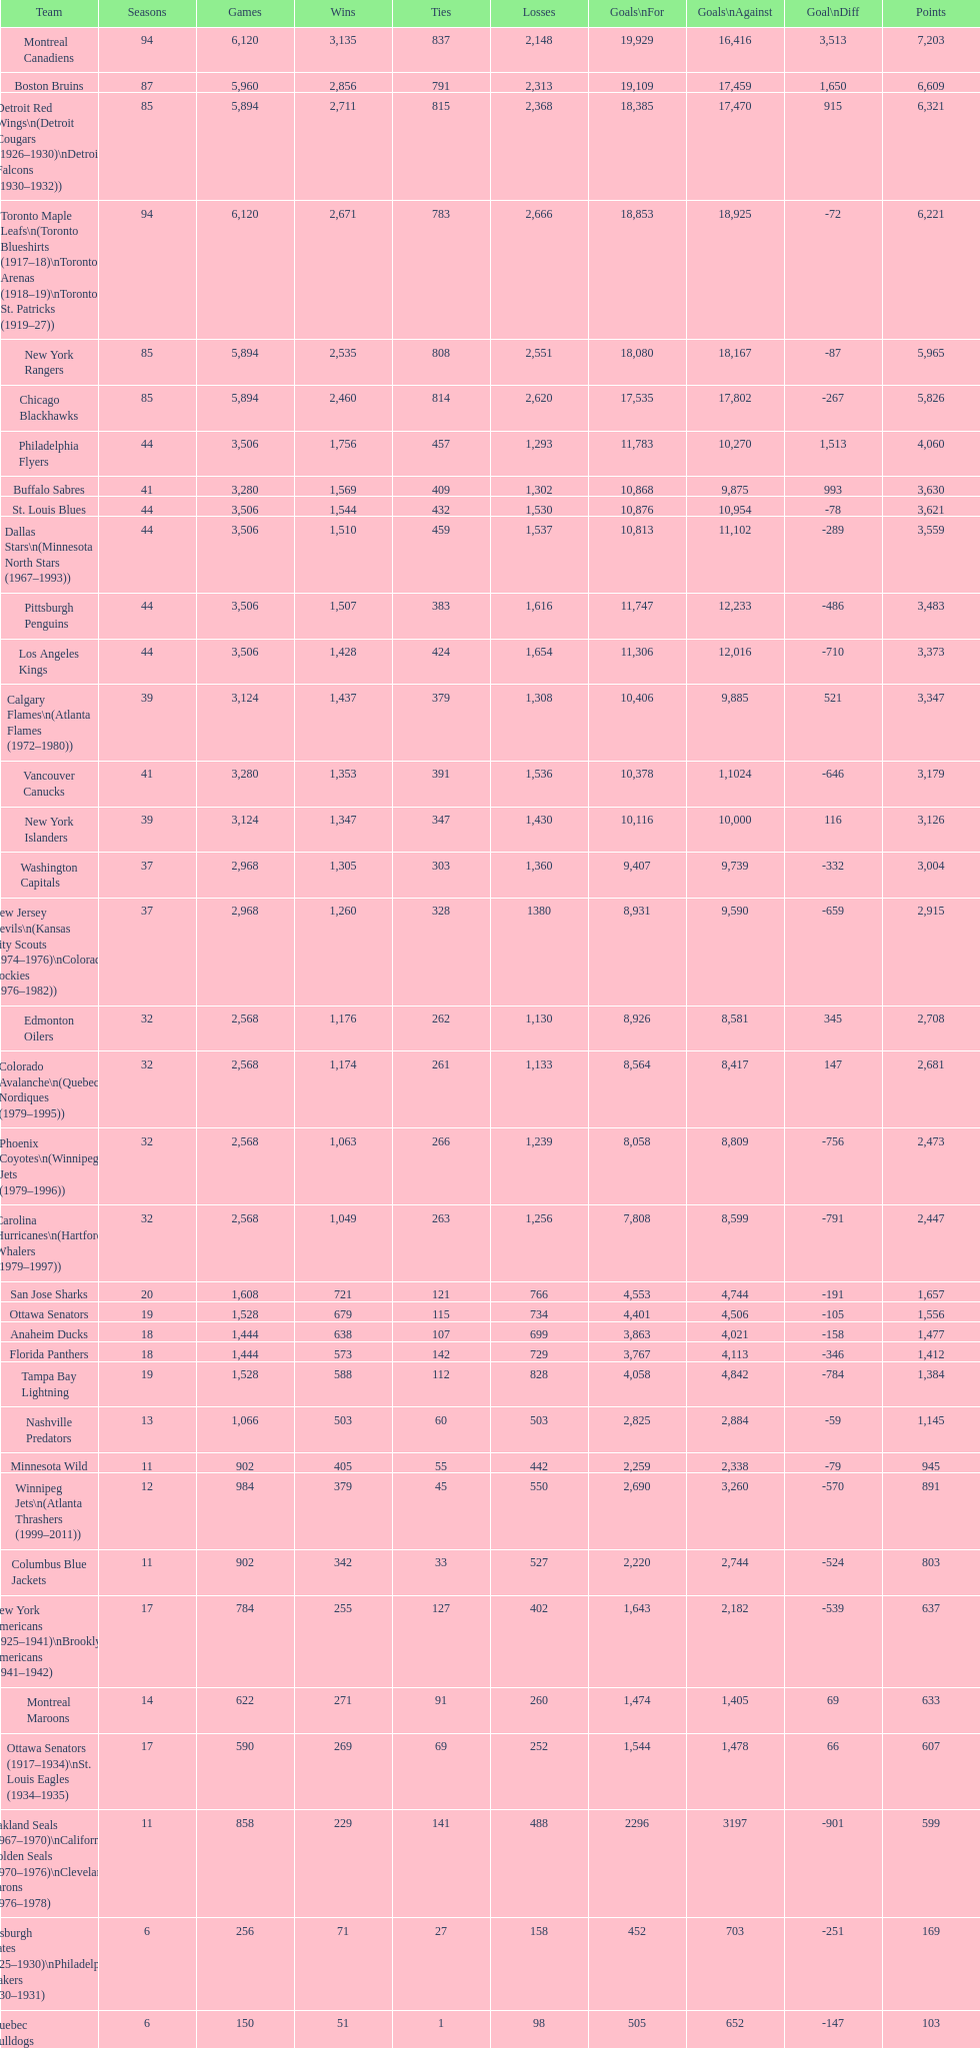How many teams have achieved over 1,500 victories? 11. 